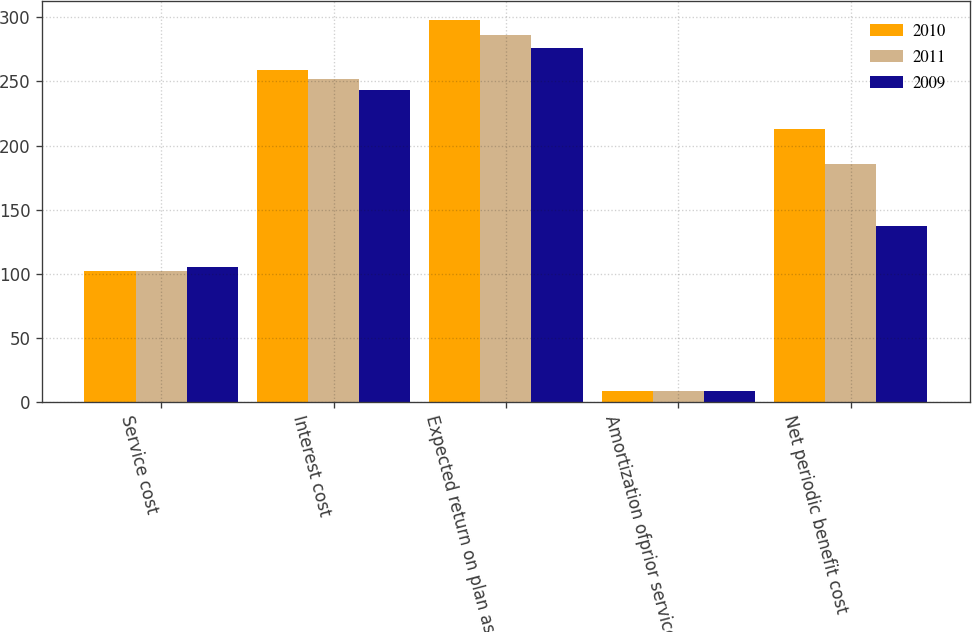<chart> <loc_0><loc_0><loc_500><loc_500><stacked_bar_chart><ecel><fcel>Service cost<fcel>Interest cost<fcel>Expected return on plan assets<fcel>Amortization ofprior service<fcel>Net periodic benefit cost<nl><fcel>2010<fcel>102<fcel>259<fcel>298<fcel>9<fcel>213<nl><fcel>2011<fcel>102<fcel>252<fcel>286<fcel>9<fcel>186<nl><fcel>2009<fcel>105<fcel>243<fcel>276<fcel>9<fcel>137<nl></chart> 